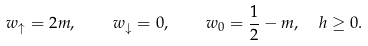<formula> <loc_0><loc_0><loc_500><loc_500>w _ { \uparrow } = 2 m , \quad w _ { \downarrow } = 0 , \quad w _ { 0 } = \frac { 1 } { 2 } - m , \ \ h \geq 0 .</formula> 